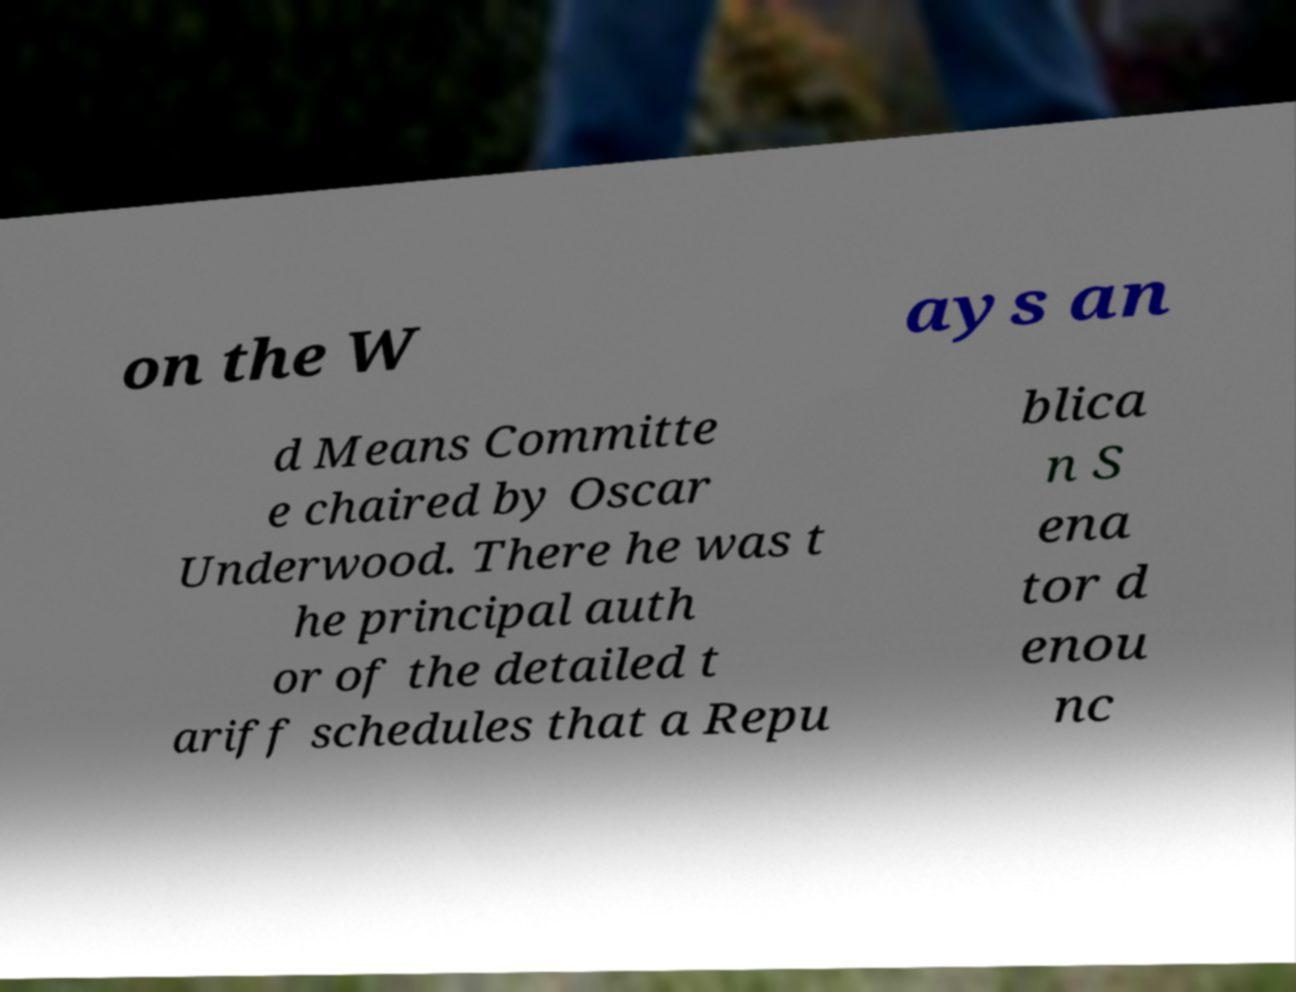I need the written content from this picture converted into text. Can you do that? on the W ays an d Means Committe e chaired by Oscar Underwood. There he was t he principal auth or of the detailed t ariff schedules that a Repu blica n S ena tor d enou nc 